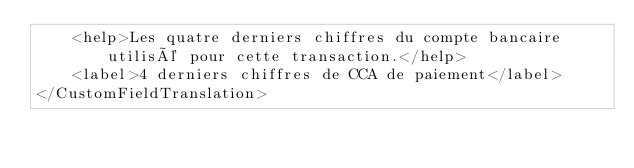<code> <loc_0><loc_0><loc_500><loc_500><_XML_>    <help>Les quatre derniers chiffres du compte bancaire utilisé pour cette transaction.</help>
    <label>4 derniers chiffres de CCA de paiement</label>
</CustomFieldTranslation>
</code> 